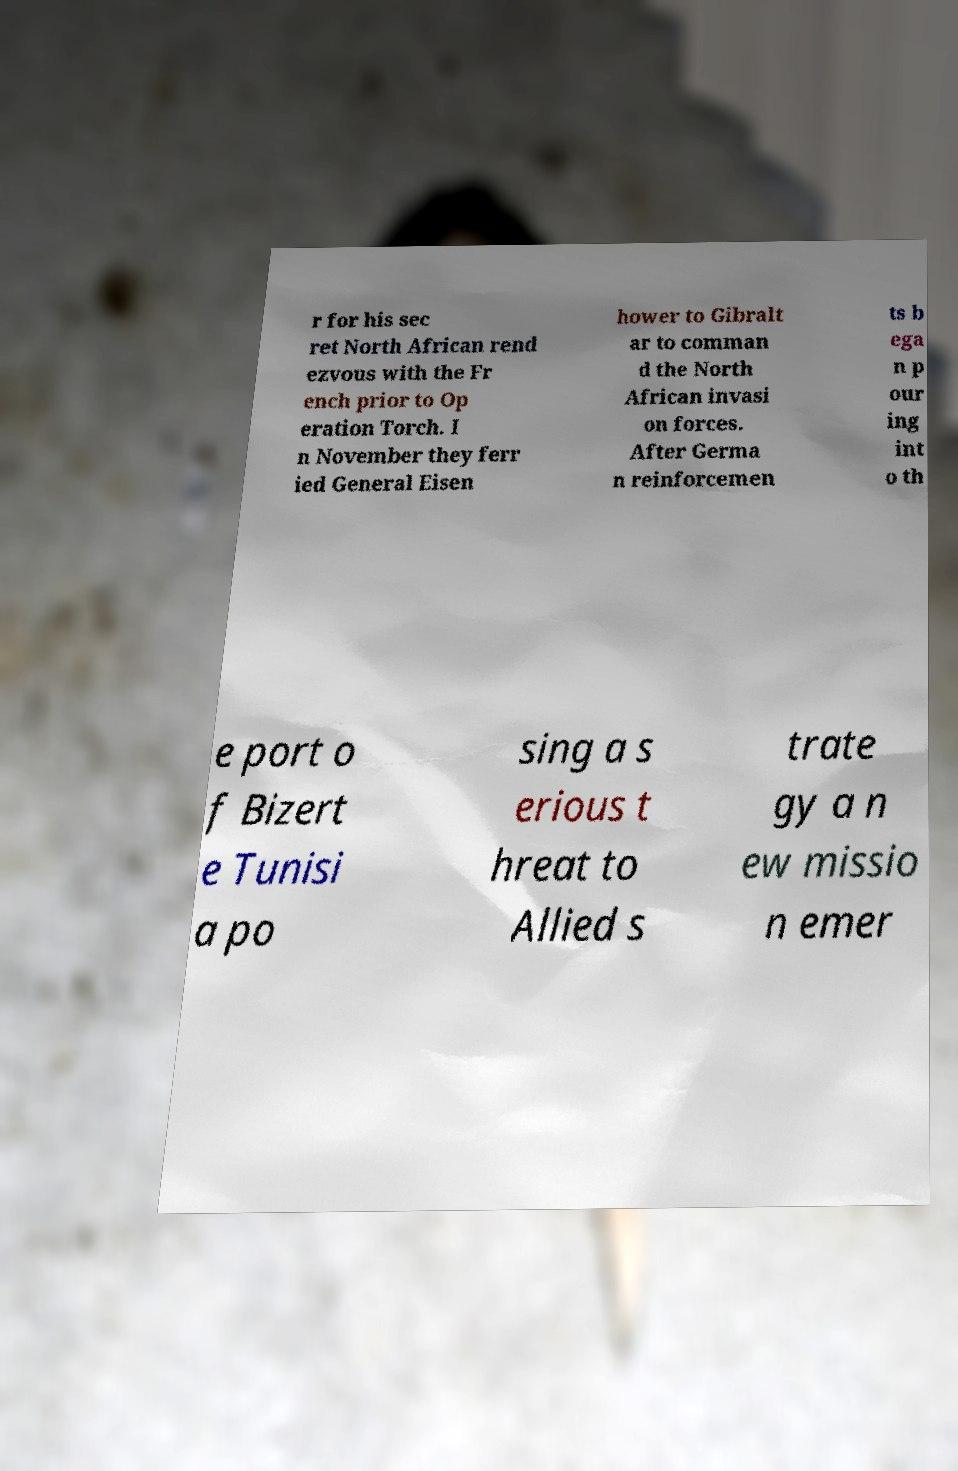There's text embedded in this image that I need extracted. Can you transcribe it verbatim? r for his sec ret North African rend ezvous with the Fr ench prior to Op eration Torch. I n November they ferr ied General Eisen hower to Gibralt ar to comman d the North African invasi on forces. After Germa n reinforcemen ts b ega n p our ing int o th e port o f Bizert e Tunisi a po sing a s erious t hreat to Allied s trate gy a n ew missio n emer 